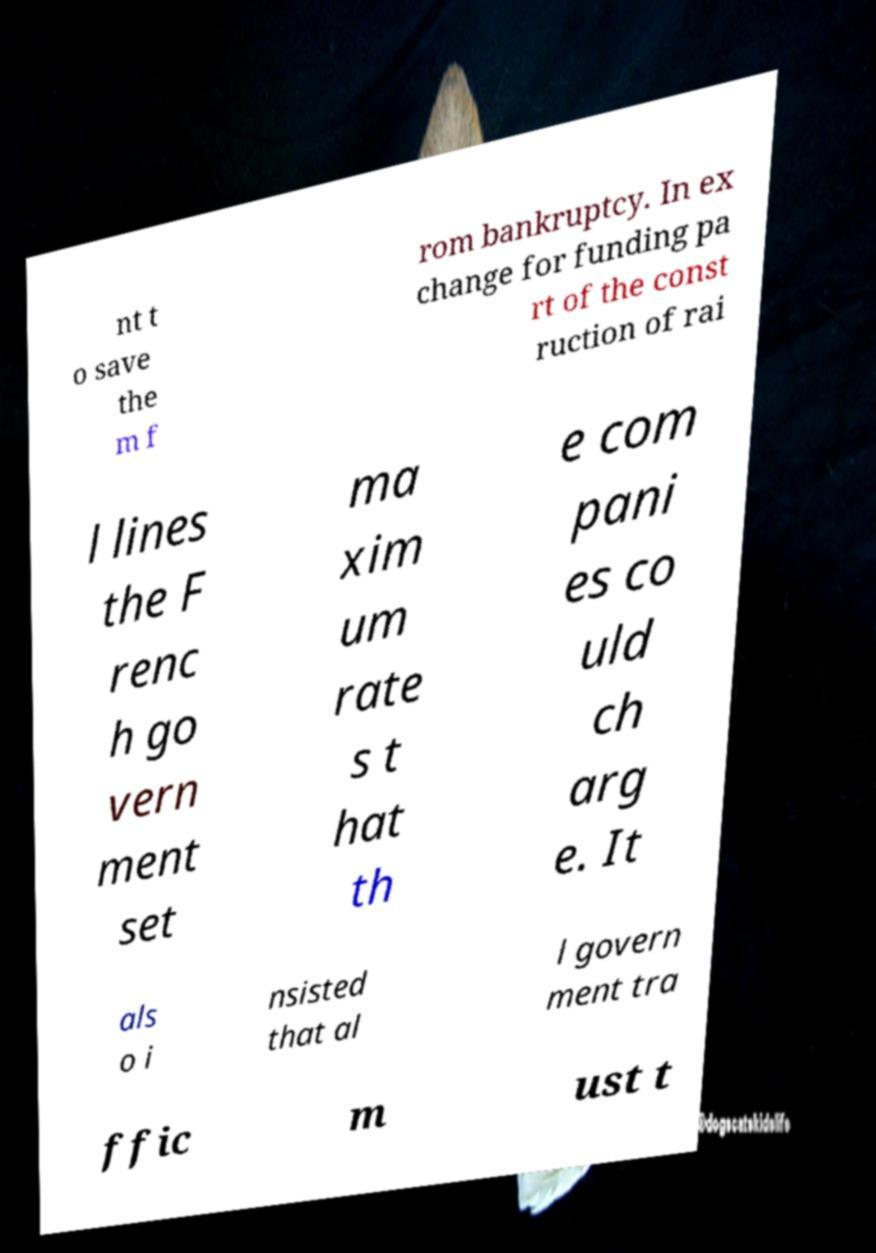I need the written content from this picture converted into text. Can you do that? nt t o save the m f rom bankruptcy. In ex change for funding pa rt of the const ruction of rai l lines the F renc h go vern ment set ma xim um rate s t hat th e com pani es co uld ch arg e. It als o i nsisted that al l govern ment tra ffic m ust t 